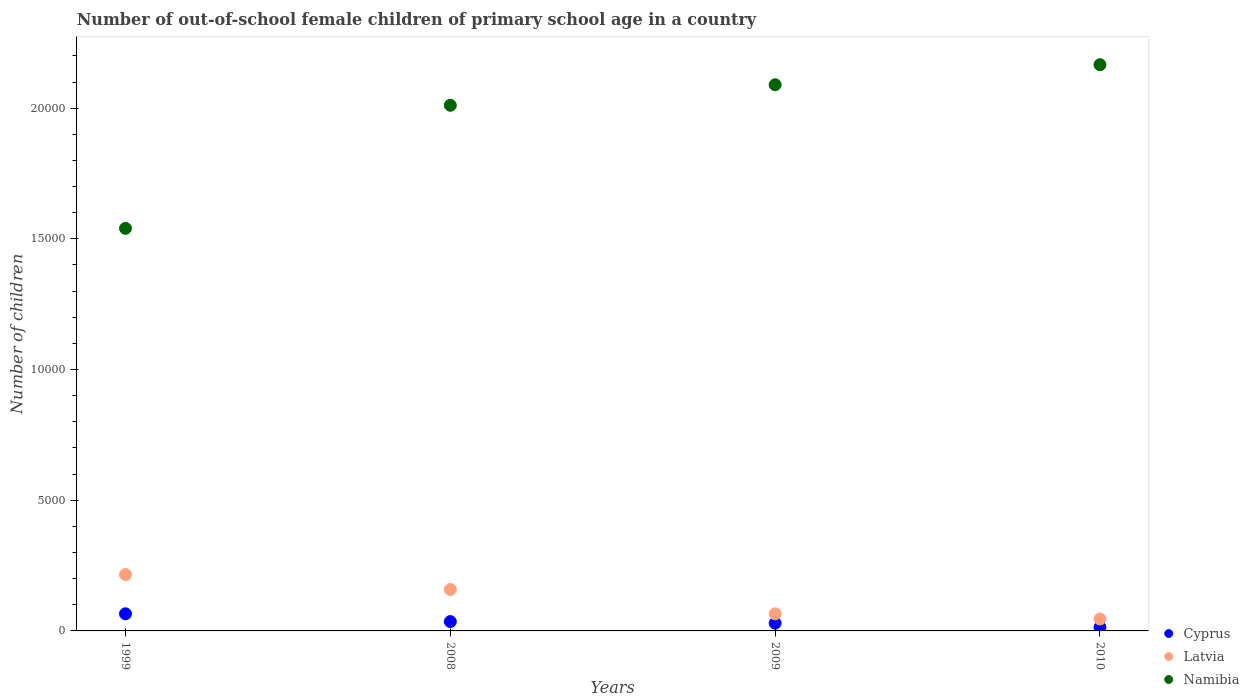Is the number of dotlines equal to the number of legend labels?
Make the answer very short. Yes. What is the number of out-of-school female children in Cyprus in 1999?
Offer a terse response. 655. Across all years, what is the maximum number of out-of-school female children in Namibia?
Ensure brevity in your answer.  2.17e+04. Across all years, what is the minimum number of out-of-school female children in Cyprus?
Provide a short and direct response. 140. What is the total number of out-of-school female children in Cyprus in the graph?
Your response must be concise. 1451. What is the difference between the number of out-of-school female children in Namibia in 1999 and that in 2008?
Offer a very short reply. -4709. What is the difference between the number of out-of-school female children in Cyprus in 2008 and the number of out-of-school female children in Namibia in 2009?
Ensure brevity in your answer.  -2.05e+04. What is the average number of out-of-school female children in Latvia per year?
Offer a very short reply. 1212.25. In the year 2008, what is the difference between the number of out-of-school female children in Cyprus and number of out-of-school female children in Latvia?
Offer a very short reply. -1226. What is the ratio of the number of out-of-school female children in Latvia in 2008 to that in 2009?
Offer a very short reply. 2.43. What is the difference between the highest and the second highest number of out-of-school female children in Namibia?
Provide a succinct answer. 767. What is the difference between the highest and the lowest number of out-of-school female children in Namibia?
Your response must be concise. 6261. Is the sum of the number of out-of-school female children in Latvia in 2009 and 2010 greater than the maximum number of out-of-school female children in Namibia across all years?
Your response must be concise. No. Does the number of out-of-school female children in Latvia monotonically increase over the years?
Give a very brief answer. No. Is the number of out-of-school female children in Latvia strictly greater than the number of out-of-school female children in Namibia over the years?
Your response must be concise. No. Is the number of out-of-school female children in Namibia strictly less than the number of out-of-school female children in Latvia over the years?
Make the answer very short. No. How many years are there in the graph?
Provide a succinct answer. 4. Does the graph contain grids?
Offer a terse response. No. How many legend labels are there?
Keep it short and to the point. 3. What is the title of the graph?
Give a very brief answer. Number of out-of-school female children of primary school age in a country. Does "Palau" appear as one of the legend labels in the graph?
Offer a terse response. No. What is the label or title of the Y-axis?
Offer a very short reply. Number of children. What is the Number of children in Cyprus in 1999?
Your answer should be compact. 655. What is the Number of children of Latvia in 1999?
Your answer should be very brief. 2157. What is the Number of children of Namibia in 1999?
Provide a short and direct response. 1.54e+04. What is the Number of children in Cyprus in 2008?
Make the answer very short. 358. What is the Number of children of Latvia in 2008?
Offer a terse response. 1584. What is the Number of children of Namibia in 2008?
Provide a short and direct response. 2.01e+04. What is the Number of children in Cyprus in 2009?
Keep it short and to the point. 298. What is the Number of children in Latvia in 2009?
Your answer should be compact. 653. What is the Number of children in Namibia in 2009?
Provide a succinct answer. 2.09e+04. What is the Number of children of Cyprus in 2010?
Offer a terse response. 140. What is the Number of children of Latvia in 2010?
Offer a very short reply. 455. What is the Number of children of Namibia in 2010?
Your answer should be very brief. 2.17e+04. Across all years, what is the maximum Number of children in Cyprus?
Offer a terse response. 655. Across all years, what is the maximum Number of children of Latvia?
Your response must be concise. 2157. Across all years, what is the maximum Number of children in Namibia?
Your response must be concise. 2.17e+04. Across all years, what is the minimum Number of children of Cyprus?
Ensure brevity in your answer.  140. Across all years, what is the minimum Number of children of Latvia?
Offer a very short reply. 455. Across all years, what is the minimum Number of children of Namibia?
Your response must be concise. 1.54e+04. What is the total Number of children in Cyprus in the graph?
Offer a very short reply. 1451. What is the total Number of children in Latvia in the graph?
Keep it short and to the point. 4849. What is the total Number of children in Namibia in the graph?
Your answer should be compact. 7.81e+04. What is the difference between the Number of children in Cyprus in 1999 and that in 2008?
Provide a short and direct response. 297. What is the difference between the Number of children of Latvia in 1999 and that in 2008?
Make the answer very short. 573. What is the difference between the Number of children in Namibia in 1999 and that in 2008?
Offer a terse response. -4709. What is the difference between the Number of children of Cyprus in 1999 and that in 2009?
Give a very brief answer. 357. What is the difference between the Number of children of Latvia in 1999 and that in 2009?
Your answer should be very brief. 1504. What is the difference between the Number of children in Namibia in 1999 and that in 2009?
Keep it short and to the point. -5494. What is the difference between the Number of children in Cyprus in 1999 and that in 2010?
Offer a very short reply. 515. What is the difference between the Number of children in Latvia in 1999 and that in 2010?
Your answer should be very brief. 1702. What is the difference between the Number of children of Namibia in 1999 and that in 2010?
Ensure brevity in your answer.  -6261. What is the difference between the Number of children of Cyprus in 2008 and that in 2009?
Your answer should be compact. 60. What is the difference between the Number of children of Latvia in 2008 and that in 2009?
Ensure brevity in your answer.  931. What is the difference between the Number of children of Namibia in 2008 and that in 2009?
Offer a terse response. -785. What is the difference between the Number of children in Cyprus in 2008 and that in 2010?
Keep it short and to the point. 218. What is the difference between the Number of children in Latvia in 2008 and that in 2010?
Provide a short and direct response. 1129. What is the difference between the Number of children of Namibia in 2008 and that in 2010?
Provide a short and direct response. -1552. What is the difference between the Number of children of Cyprus in 2009 and that in 2010?
Your answer should be compact. 158. What is the difference between the Number of children of Latvia in 2009 and that in 2010?
Keep it short and to the point. 198. What is the difference between the Number of children in Namibia in 2009 and that in 2010?
Offer a very short reply. -767. What is the difference between the Number of children of Cyprus in 1999 and the Number of children of Latvia in 2008?
Offer a terse response. -929. What is the difference between the Number of children of Cyprus in 1999 and the Number of children of Namibia in 2008?
Provide a short and direct response. -1.95e+04. What is the difference between the Number of children of Latvia in 1999 and the Number of children of Namibia in 2008?
Make the answer very short. -1.80e+04. What is the difference between the Number of children in Cyprus in 1999 and the Number of children in Latvia in 2009?
Your answer should be compact. 2. What is the difference between the Number of children of Cyprus in 1999 and the Number of children of Namibia in 2009?
Ensure brevity in your answer.  -2.02e+04. What is the difference between the Number of children of Latvia in 1999 and the Number of children of Namibia in 2009?
Ensure brevity in your answer.  -1.87e+04. What is the difference between the Number of children of Cyprus in 1999 and the Number of children of Namibia in 2010?
Keep it short and to the point. -2.10e+04. What is the difference between the Number of children in Latvia in 1999 and the Number of children in Namibia in 2010?
Your answer should be compact. -1.95e+04. What is the difference between the Number of children of Cyprus in 2008 and the Number of children of Latvia in 2009?
Give a very brief answer. -295. What is the difference between the Number of children in Cyprus in 2008 and the Number of children in Namibia in 2009?
Offer a terse response. -2.05e+04. What is the difference between the Number of children of Latvia in 2008 and the Number of children of Namibia in 2009?
Your answer should be compact. -1.93e+04. What is the difference between the Number of children in Cyprus in 2008 and the Number of children in Latvia in 2010?
Provide a succinct answer. -97. What is the difference between the Number of children in Cyprus in 2008 and the Number of children in Namibia in 2010?
Offer a very short reply. -2.13e+04. What is the difference between the Number of children of Latvia in 2008 and the Number of children of Namibia in 2010?
Offer a very short reply. -2.01e+04. What is the difference between the Number of children in Cyprus in 2009 and the Number of children in Latvia in 2010?
Offer a very short reply. -157. What is the difference between the Number of children of Cyprus in 2009 and the Number of children of Namibia in 2010?
Provide a short and direct response. -2.14e+04. What is the difference between the Number of children in Latvia in 2009 and the Number of children in Namibia in 2010?
Give a very brief answer. -2.10e+04. What is the average Number of children of Cyprus per year?
Give a very brief answer. 362.75. What is the average Number of children of Latvia per year?
Your response must be concise. 1212.25. What is the average Number of children of Namibia per year?
Provide a short and direct response. 1.95e+04. In the year 1999, what is the difference between the Number of children of Cyprus and Number of children of Latvia?
Make the answer very short. -1502. In the year 1999, what is the difference between the Number of children in Cyprus and Number of children in Namibia?
Provide a succinct answer. -1.47e+04. In the year 1999, what is the difference between the Number of children in Latvia and Number of children in Namibia?
Provide a short and direct response. -1.32e+04. In the year 2008, what is the difference between the Number of children in Cyprus and Number of children in Latvia?
Provide a short and direct response. -1226. In the year 2008, what is the difference between the Number of children of Cyprus and Number of children of Namibia?
Make the answer very short. -1.98e+04. In the year 2008, what is the difference between the Number of children in Latvia and Number of children in Namibia?
Make the answer very short. -1.85e+04. In the year 2009, what is the difference between the Number of children in Cyprus and Number of children in Latvia?
Ensure brevity in your answer.  -355. In the year 2009, what is the difference between the Number of children in Cyprus and Number of children in Namibia?
Give a very brief answer. -2.06e+04. In the year 2009, what is the difference between the Number of children in Latvia and Number of children in Namibia?
Your answer should be very brief. -2.02e+04. In the year 2010, what is the difference between the Number of children in Cyprus and Number of children in Latvia?
Offer a terse response. -315. In the year 2010, what is the difference between the Number of children of Cyprus and Number of children of Namibia?
Your answer should be very brief. -2.15e+04. In the year 2010, what is the difference between the Number of children of Latvia and Number of children of Namibia?
Make the answer very short. -2.12e+04. What is the ratio of the Number of children in Cyprus in 1999 to that in 2008?
Your answer should be very brief. 1.83. What is the ratio of the Number of children in Latvia in 1999 to that in 2008?
Your answer should be very brief. 1.36. What is the ratio of the Number of children in Namibia in 1999 to that in 2008?
Make the answer very short. 0.77. What is the ratio of the Number of children of Cyprus in 1999 to that in 2009?
Your response must be concise. 2.2. What is the ratio of the Number of children in Latvia in 1999 to that in 2009?
Ensure brevity in your answer.  3.3. What is the ratio of the Number of children of Namibia in 1999 to that in 2009?
Your answer should be compact. 0.74. What is the ratio of the Number of children of Cyprus in 1999 to that in 2010?
Your response must be concise. 4.68. What is the ratio of the Number of children of Latvia in 1999 to that in 2010?
Make the answer very short. 4.74. What is the ratio of the Number of children in Namibia in 1999 to that in 2010?
Give a very brief answer. 0.71. What is the ratio of the Number of children of Cyprus in 2008 to that in 2009?
Your answer should be compact. 1.2. What is the ratio of the Number of children of Latvia in 2008 to that in 2009?
Your response must be concise. 2.43. What is the ratio of the Number of children of Namibia in 2008 to that in 2009?
Your response must be concise. 0.96. What is the ratio of the Number of children of Cyprus in 2008 to that in 2010?
Make the answer very short. 2.56. What is the ratio of the Number of children of Latvia in 2008 to that in 2010?
Provide a short and direct response. 3.48. What is the ratio of the Number of children in Namibia in 2008 to that in 2010?
Ensure brevity in your answer.  0.93. What is the ratio of the Number of children of Cyprus in 2009 to that in 2010?
Keep it short and to the point. 2.13. What is the ratio of the Number of children of Latvia in 2009 to that in 2010?
Give a very brief answer. 1.44. What is the ratio of the Number of children in Namibia in 2009 to that in 2010?
Offer a terse response. 0.96. What is the difference between the highest and the second highest Number of children in Cyprus?
Your answer should be very brief. 297. What is the difference between the highest and the second highest Number of children in Latvia?
Keep it short and to the point. 573. What is the difference between the highest and the second highest Number of children of Namibia?
Offer a terse response. 767. What is the difference between the highest and the lowest Number of children of Cyprus?
Give a very brief answer. 515. What is the difference between the highest and the lowest Number of children of Latvia?
Give a very brief answer. 1702. What is the difference between the highest and the lowest Number of children of Namibia?
Provide a succinct answer. 6261. 